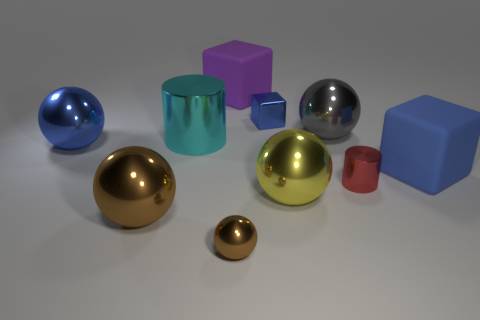Add 4 purple rubber blocks. How many purple rubber blocks are left? 5 Add 9 large cyan metal objects. How many large cyan metal objects exist? 10 Subtract all cyan cylinders. How many cylinders are left? 1 Subtract all large balls. How many balls are left? 1 Subtract 0 brown blocks. How many objects are left? 10 Subtract all cubes. How many objects are left? 7 Subtract 2 cylinders. How many cylinders are left? 0 Subtract all gray blocks. Subtract all blue cylinders. How many blocks are left? 3 Subtract all green spheres. How many purple blocks are left? 1 Subtract all red matte cubes. Subtract all large yellow shiny things. How many objects are left? 9 